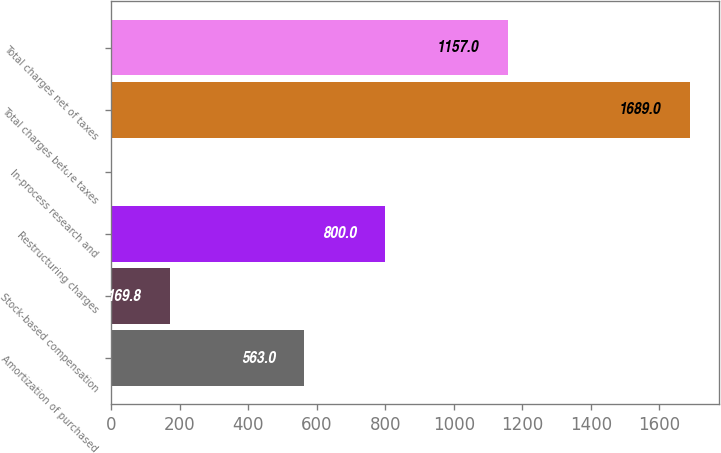Convert chart to OTSL. <chart><loc_0><loc_0><loc_500><loc_500><bar_chart><fcel>Amortization of purchased<fcel>Stock-based compensation<fcel>Restructuring charges<fcel>In-process research and<fcel>Total charges before taxes<fcel>Total charges net of taxes<nl><fcel>563<fcel>169.8<fcel>800<fcel>1<fcel>1689<fcel>1157<nl></chart> 